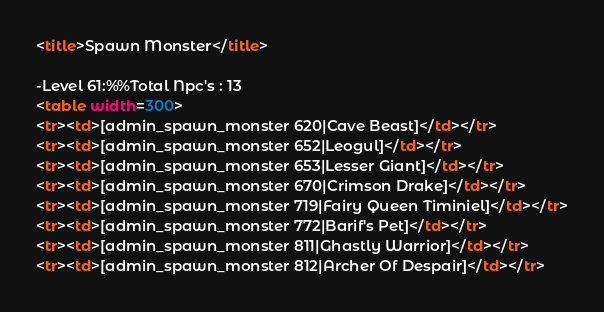<code> <loc_0><loc_0><loc_500><loc_500><_HTML_><title>Spawn Monster</title>

-Level 61:%%Total Npc's : 13
<table width=300>
<tr><td>[admin_spawn_monster 620|Cave Beast]</td></tr>
<tr><td>[admin_spawn_monster 652|Leogul]</td></tr>
<tr><td>[admin_spawn_monster 653|Lesser Giant]</td></tr>
<tr><td>[admin_spawn_monster 670|Crimson Drake]</td></tr>
<tr><td>[admin_spawn_monster 719|Fairy Queen Timiniel]</td></tr>
<tr><td>[admin_spawn_monster 772|Barif's Pet]</td></tr>
<tr><td>[admin_spawn_monster 811|Ghastly Warrior]</td></tr>
<tr><td>[admin_spawn_monster 812|Archer Of Despair]</td></tr></code> 